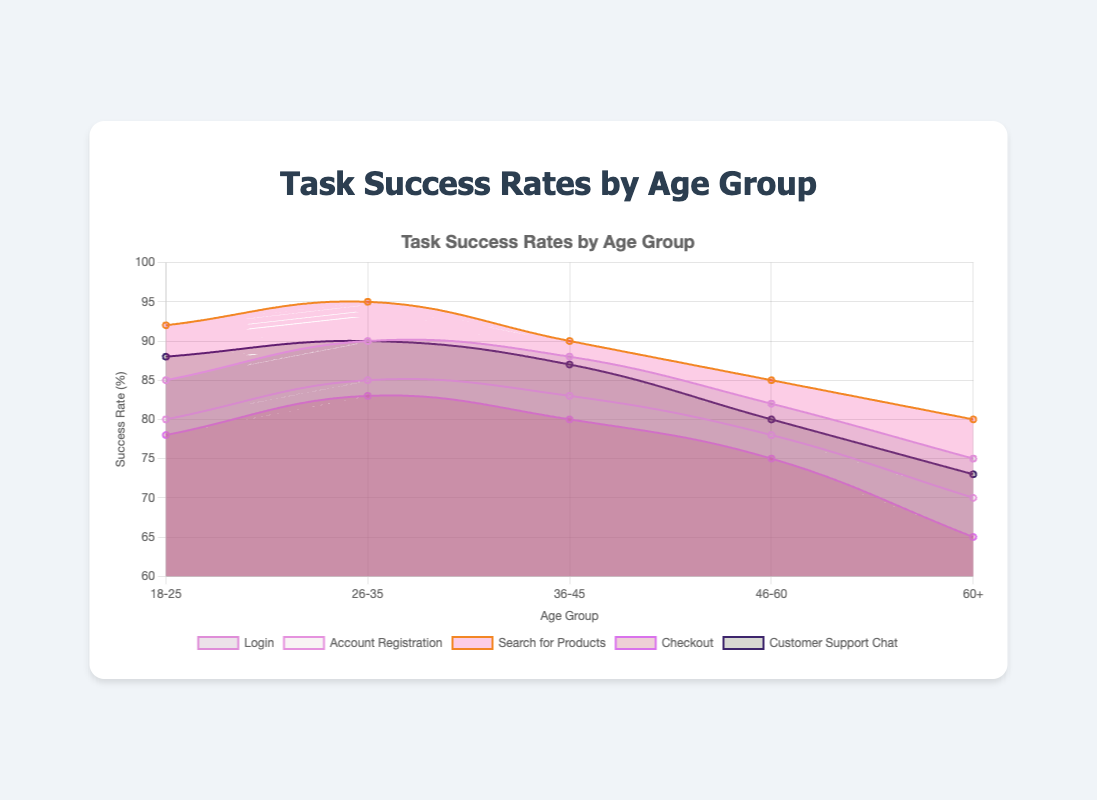What is the title of the chart? The title is typically located at the top-center of the chart. It provides an overview of what the chart represents. In this case, it says "Task Success Rates by Age Group".
Answer: Task Success Rates by Age Group What is the highest success rate for "Search for Products"? Locate the "Search for Products" line in the chart and identify the point with the highest value. The peak point is at the age group "26-35" with the value of 95.
Answer: 95 Which age group has the lowest success rate for "Checkout"? Follow the "Checkout" line and find the minimum point. It is at the age group "60+" with a success rate of 65.
Answer: 60+ Compare the success rates of "Login" and "Customer Support Chat" for the age group "36-45". Identify the points for both tasks under the age group "36-45" and compare their values. "Login" has 88, and "Customer Support Chat" has 87. The "Login" task is slightly higher.
Answer: Login has 88, and Customer Support Chat has 87 What is the average success rate across all tasks for the age group "46-60"? For each task, find the success rate for the age group "46-60" and calculate the average: (82 + 78 + 85 + 75 + 80) / 5 = 80.
Answer: 80 Identify which task has the most consistent success rates across all age groups. Check the lines and look for the one with the least variation in values. "Customer Support Chat" has values close to each other (ranging from 73 to 90), indicating consistency.
Answer: Customer Support Chat What is the trend of success rates for the "Account Registration" task across age groups? Follow the "Account Registration" line and observe the changes. The success rate declines as the age increases from "18-25" to "60+".
Answer: Decreasing trend How many data points are represented for each task on the chart? Each task has success rates for five age groups: "18-25", "26-35", "36-45", "46-60", and "60+".
Answer: 5 data points per task Which age group has the highest average success rate across all tasks? Calculate the average success rate for each age group and compare: 
"18-25" (85+80+92+78+88)/5 = 84.6,
"26-35" (90+85+95+83+90)/5 = 88.6, 
"36-45" (88+83+90+80+87)/5 = 85.6,
"46-60" (82+78+85+75+80)/5 = 80,
"60+" (75+70+80+65+73)/5 = 72.6. 
The highest average is for "26-35" with 88.6.
Answer: 26-35 